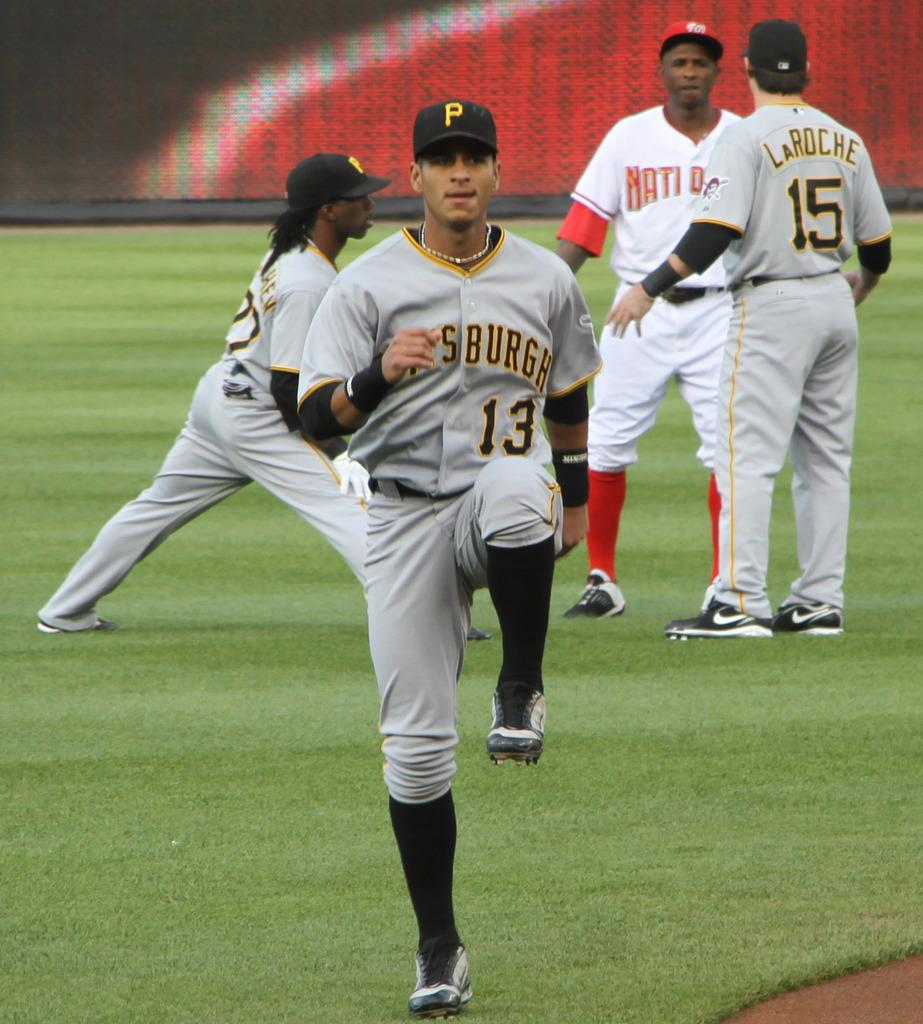<image>
Describe the image concisely. Baseball players warming up on a field and one of the players is named La Roche. 